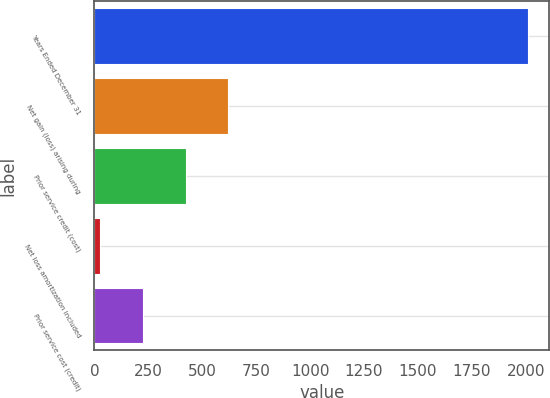<chart> <loc_0><loc_0><loc_500><loc_500><bar_chart><fcel>Years Ended December 31<fcel>Net gain (loss) arising during<fcel>Prior service credit (cost)<fcel>Net loss amortization included<fcel>Prior service cost (credit)<nl><fcel>2008<fcel>620.6<fcel>422.4<fcel>26<fcel>224.2<nl></chart> 